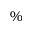Convert formula to latex. <formula><loc_0><loc_0><loc_500><loc_500>\%</formula> 